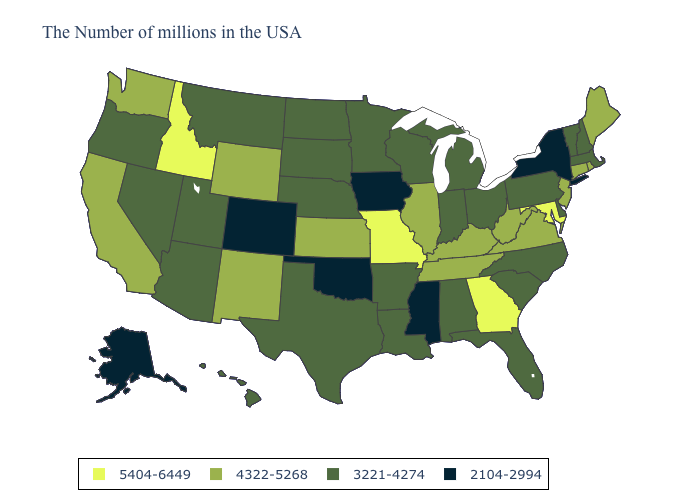What is the value of Nebraska?
Concise answer only. 3221-4274. Does the map have missing data?
Quick response, please. No. What is the value of Georgia?
Concise answer only. 5404-6449. What is the lowest value in the USA?
Quick response, please. 2104-2994. What is the highest value in states that border Kentucky?
Write a very short answer. 5404-6449. Among the states that border Texas , does Louisiana have the highest value?
Answer briefly. No. Does Iowa have the lowest value in the MidWest?
Give a very brief answer. Yes. What is the value of Tennessee?
Answer briefly. 4322-5268. How many symbols are there in the legend?
Concise answer only. 4. What is the highest value in the USA?
Short answer required. 5404-6449. Which states have the lowest value in the South?
Give a very brief answer. Mississippi, Oklahoma. What is the value of Idaho?
Give a very brief answer. 5404-6449. Name the states that have a value in the range 2104-2994?
Keep it brief. New York, Mississippi, Iowa, Oklahoma, Colorado, Alaska. Name the states that have a value in the range 5404-6449?
Be succinct. Maryland, Georgia, Missouri, Idaho. What is the value of South Carolina?
Give a very brief answer. 3221-4274. 